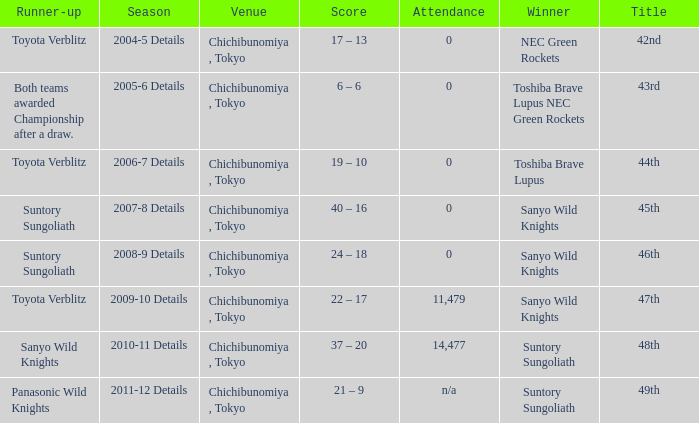What is the Attendance number for the title of 44th? 0.0. 